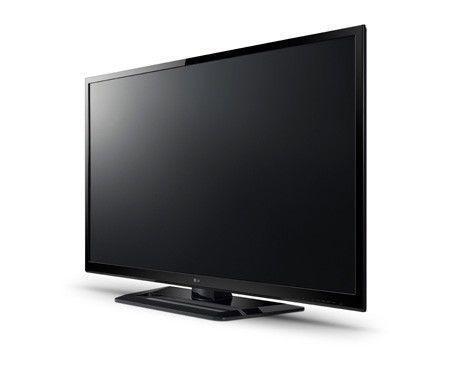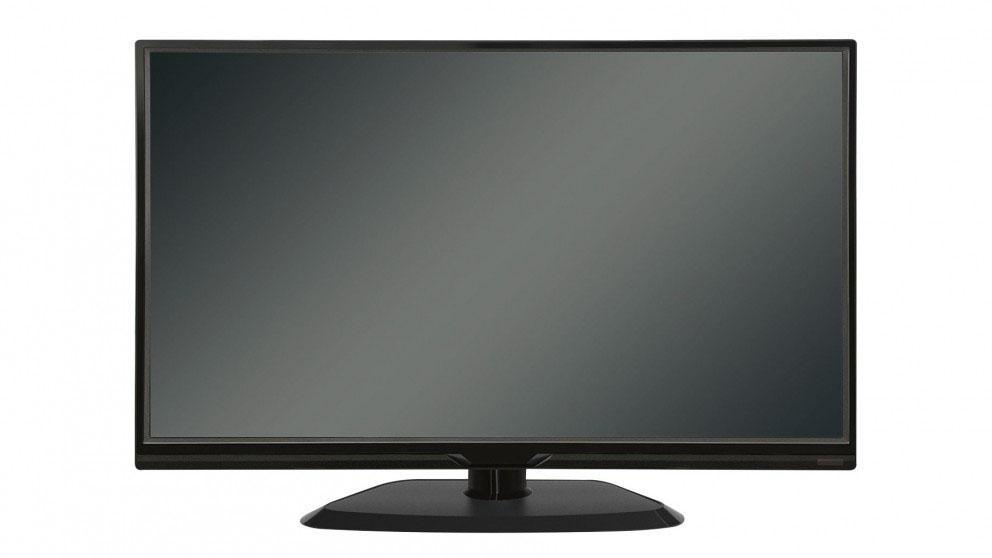The first image is the image on the left, the second image is the image on the right. For the images shown, is this caption "The left and right image contains the same number of computer monitors with one being silver." true? Answer yes or no. No. The first image is the image on the left, the second image is the image on the right. Considering the images on both sides, is "Each image contains exactly one upright TV on a stand, and one image depicts a TV head-on, while the other image depicts a TV at an angle." valid? Answer yes or no. Yes. 